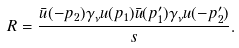Convert formula to latex. <formula><loc_0><loc_0><loc_500><loc_500>R = \frac { \bar { u } ( - p _ { 2 } ) \gamma _ { \nu } u ( p _ { 1 } ) \bar { u } ( p ^ { \prime } _ { 1 } ) \gamma _ { \nu } u ( - p ^ { \prime } _ { 2 } ) } { s } .</formula> 